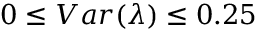Convert formula to latex. <formula><loc_0><loc_0><loc_500><loc_500>0 \leq V a r ( \lambda ) \leq 0 . 2 5</formula> 